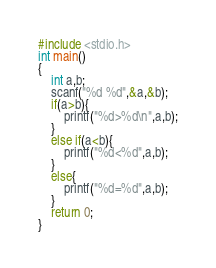Convert code to text. <code><loc_0><loc_0><loc_500><loc_500><_C_>#include <stdio.h>
int main()
{
	int a,b;
	scanf("%d %d",&a,&b);
	if(a>b){
		printf("%d>%d\n",a,b);
	}
	else if(a<b){
		printf("%d<%d",a,b);
	}
	else{
		printf("%d=%d",a,b);
	}
	return 0;
}</code> 